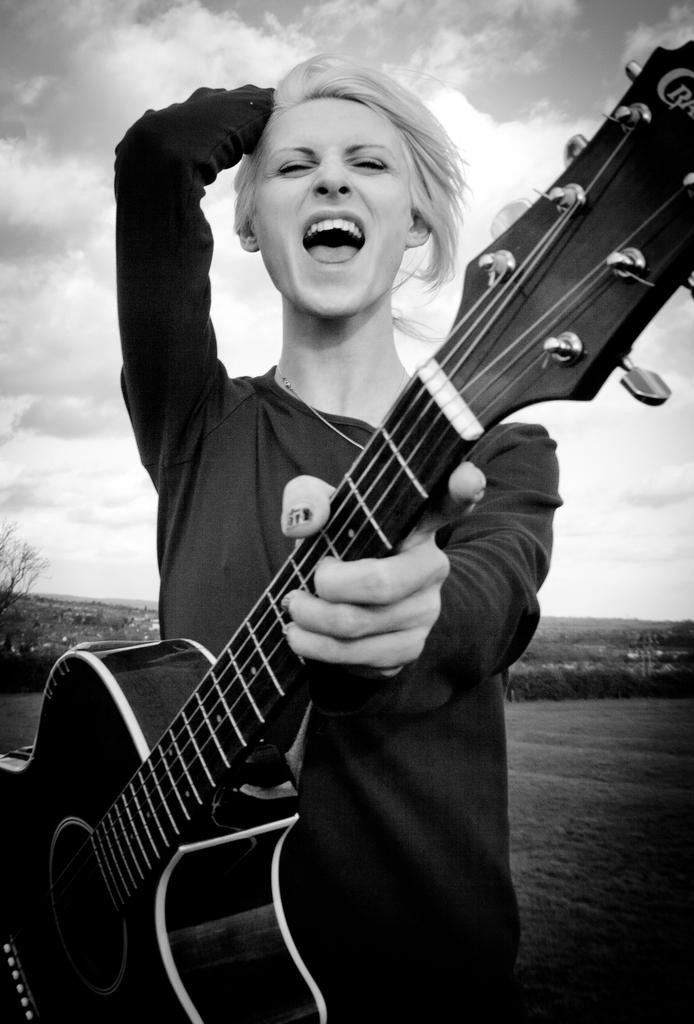What is the main subject of the image? There is a person in the image. What is the person holding in the image? The person is holding a guitar. What can be seen in the background of the image? There is sky visible in the background of the image. What type of observation can be made about the camera in the image? There is no camera present in the image. Can you describe the arch in the image? There is no arch present in the image. 